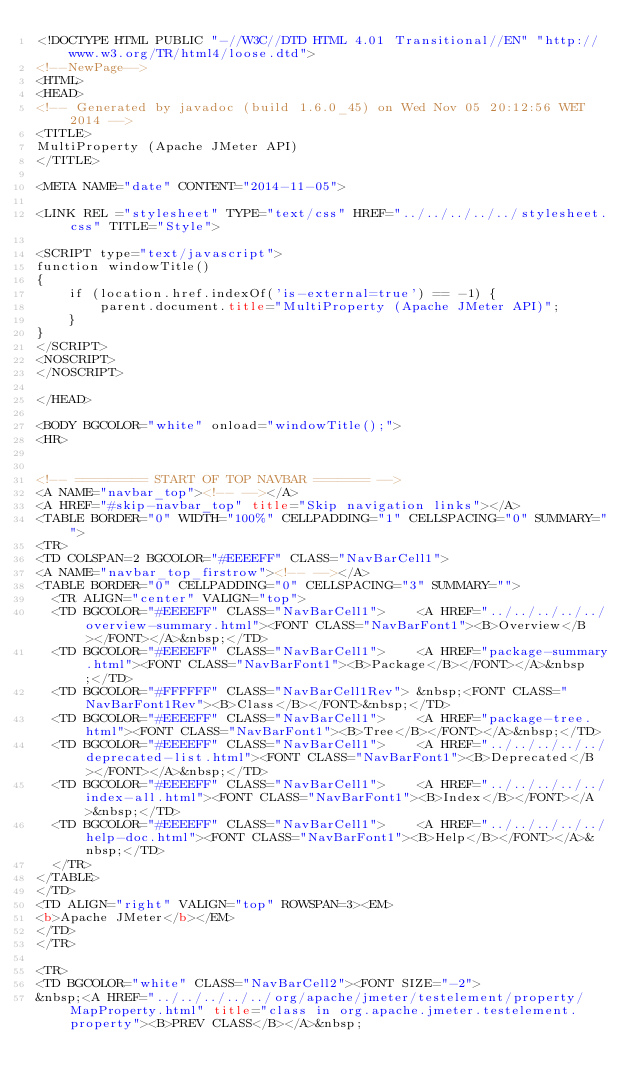Convert code to text. <code><loc_0><loc_0><loc_500><loc_500><_HTML_><!DOCTYPE HTML PUBLIC "-//W3C//DTD HTML 4.01 Transitional//EN" "http://www.w3.org/TR/html4/loose.dtd">
<!--NewPage-->
<HTML>
<HEAD>
<!-- Generated by javadoc (build 1.6.0_45) on Wed Nov 05 20:12:56 WET 2014 -->
<TITLE>
MultiProperty (Apache JMeter API)
</TITLE>

<META NAME="date" CONTENT="2014-11-05">

<LINK REL ="stylesheet" TYPE="text/css" HREF="../../../../../stylesheet.css" TITLE="Style">

<SCRIPT type="text/javascript">
function windowTitle()
{
    if (location.href.indexOf('is-external=true') == -1) {
        parent.document.title="MultiProperty (Apache JMeter API)";
    }
}
</SCRIPT>
<NOSCRIPT>
</NOSCRIPT>

</HEAD>

<BODY BGCOLOR="white" onload="windowTitle();">
<HR>


<!-- ========= START OF TOP NAVBAR ======= -->
<A NAME="navbar_top"><!-- --></A>
<A HREF="#skip-navbar_top" title="Skip navigation links"></A>
<TABLE BORDER="0" WIDTH="100%" CELLPADDING="1" CELLSPACING="0" SUMMARY="">
<TR>
<TD COLSPAN=2 BGCOLOR="#EEEEFF" CLASS="NavBarCell1">
<A NAME="navbar_top_firstrow"><!-- --></A>
<TABLE BORDER="0" CELLPADDING="0" CELLSPACING="3" SUMMARY="">
  <TR ALIGN="center" VALIGN="top">
  <TD BGCOLOR="#EEEEFF" CLASS="NavBarCell1">    <A HREF="../../../../../overview-summary.html"><FONT CLASS="NavBarFont1"><B>Overview</B></FONT></A>&nbsp;</TD>
  <TD BGCOLOR="#EEEEFF" CLASS="NavBarCell1">    <A HREF="package-summary.html"><FONT CLASS="NavBarFont1"><B>Package</B></FONT></A>&nbsp;</TD>
  <TD BGCOLOR="#FFFFFF" CLASS="NavBarCell1Rev"> &nbsp;<FONT CLASS="NavBarFont1Rev"><B>Class</B></FONT>&nbsp;</TD>
  <TD BGCOLOR="#EEEEFF" CLASS="NavBarCell1">    <A HREF="package-tree.html"><FONT CLASS="NavBarFont1"><B>Tree</B></FONT></A>&nbsp;</TD>
  <TD BGCOLOR="#EEEEFF" CLASS="NavBarCell1">    <A HREF="../../../../../deprecated-list.html"><FONT CLASS="NavBarFont1"><B>Deprecated</B></FONT></A>&nbsp;</TD>
  <TD BGCOLOR="#EEEEFF" CLASS="NavBarCell1">    <A HREF="../../../../../index-all.html"><FONT CLASS="NavBarFont1"><B>Index</B></FONT></A>&nbsp;</TD>
  <TD BGCOLOR="#EEEEFF" CLASS="NavBarCell1">    <A HREF="../../../../../help-doc.html"><FONT CLASS="NavBarFont1"><B>Help</B></FONT></A>&nbsp;</TD>
  </TR>
</TABLE>
</TD>
<TD ALIGN="right" VALIGN="top" ROWSPAN=3><EM>
<b>Apache JMeter</b></EM>
</TD>
</TR>

<TR>
<TD BGCOLOR="white" CLASS="NavBarCell2"><FONT SIZE="-2">
&nbsp;<A HREF="../../../../../org/apache/jmeter/testelement/property/MapProperty.html" title="class in org.apache.jmeter.testelement.property"><B>PREV CLASS</B></A>&nbsp;</code> 